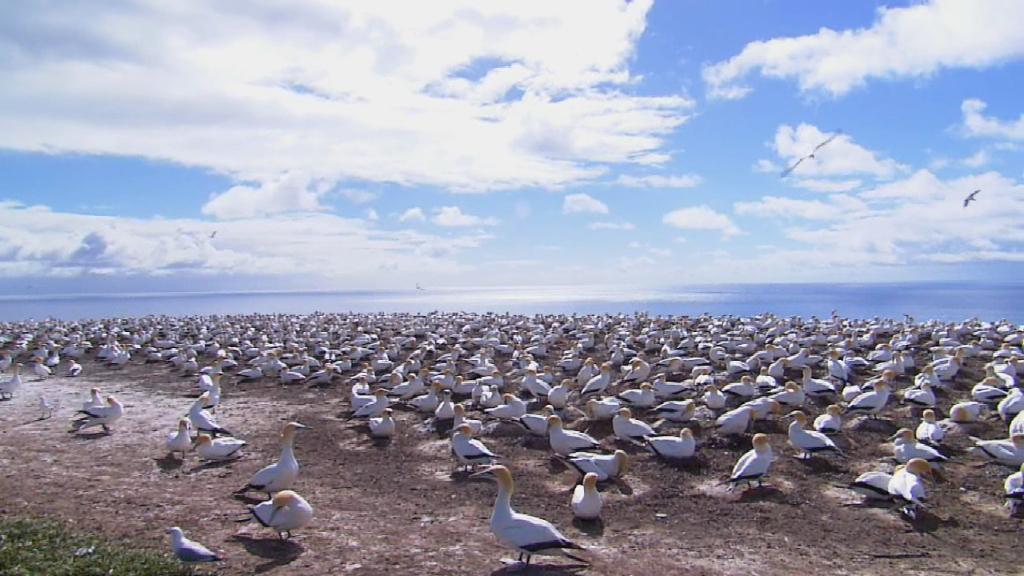In one or two sentences, can you explain what this image depicts? In the picture I can see white color birds among them some are on the ground and some are flying in the air. In the background I can see the water and the sky. 